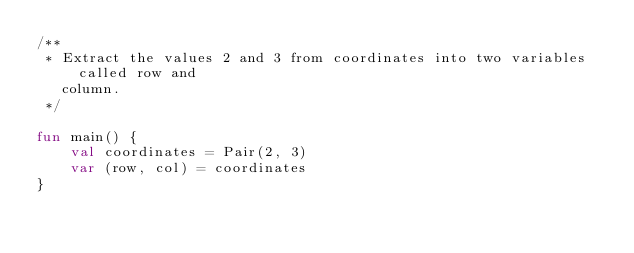Convert code to text. <code><loc_0><loc_0><loc_500><loc_500><_Kotlin_>/**
 * Extract the values 2 and 3 from coordinates into two variables called row and
   column.
 */

fun main() {
    val coordinates = Pair(2, 3)
    var (row, col) = coordinates
}</code> 